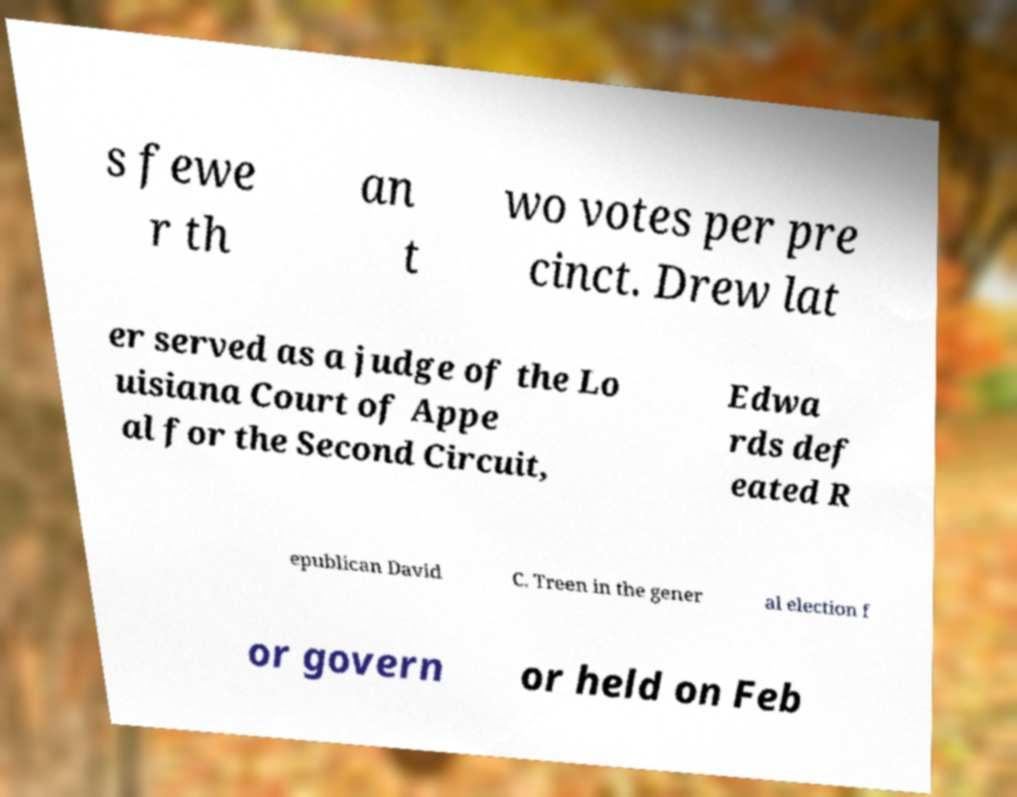There's text embedded in this image that I need extracted. Can you transcribe it verbatim? s fewe r th an t wo votes per pre cinct. Drew lat er served as a judge of the Lo uisiana Court of Appe al for the Second Circuit, Edwa rds def eated R epublican David C. Treen in the gener al election f or govern or held on Feb 